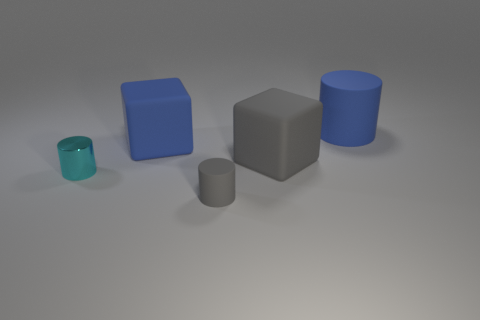Add 1 big red metallic cubes. How many objects exist? 6 Subtract all gray rubber cylinders. How many cylinders are left? 2 Subtract all blue cubes. How many cubes are left? 1 Subtract 0 yellow cylinders. How many objects are left? 5 Subtract all cubes. How many objects are left? 3 Subtract 1 cubes. How many cubes are left? 1 Subtract all blue cylinders. Subtract all red blocks. How many cylinders are left? 2 Subtract all red balls. How many blue cubes are left? 1 Subtract all small matte cylinders. Subtract all big cubes. How many objects are left? 2 Add 5 tiny rubber things. How many tiny rubber things are left? 6 